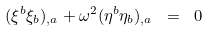Convert formula to latex. <formula><loc_0><loc_0><loc_500><loc_500>( \xi ^ { b } \xi _ { b } ) _ { , a } + \omega ^ { 2 } ( \eta ^ { b } \eta _ { b } ) _ { , a } \ = \ 0</formula> 